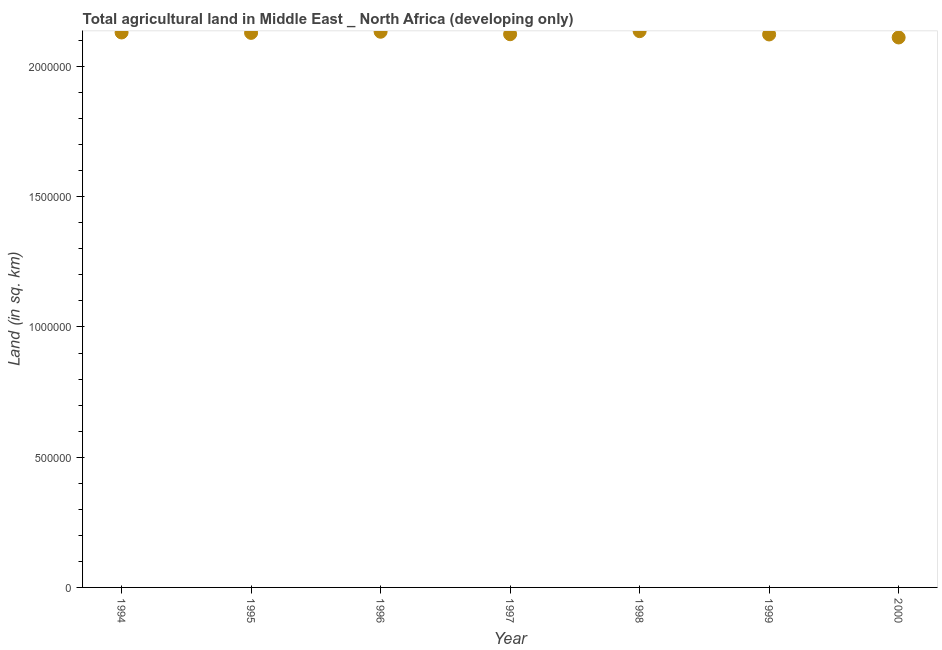What is the agricultural land in 1997?
Provide a short and direct response. 2.12e+06. Across all years, what is the maximum agricultural land?
Your answer should be very brief. 2.14e+06. Across all years, what is the minimum agricultural land?
Make the answer very short. 2.11e+06. In which year was the agricultural land minimum?
Offer a terse response. 2000. What is the sum of the agricultural land?
Provide a succinct answer. 1.49e+07. What is the difference between the agricultural land in 1996 and 1997?
Ensure brevity in your answer.  9495.4. What is the average agricultural land per year?
Ensure brevity in your answer.  2.13e+06. What is the median agricultural land?
Your answer should be very brief. 2.13e+06. In how many years, is the agricultural land greater than 700000 sq. km?
Provide a short and direct response. 7. What is the ratio of the agricultural land in 1998 to that in 2000?
Your answer should be very brief. 1.01. What is the difference between the highest and the second highest agricultural land?
Offer a terse response. 2321.6. What is the difference between the highest and the lowest agricultural land?
Your answer should be compact. 2.43e+04. In how many years, is the agricultural land greater than the average agricultural land taken over all years?
Your answer should be very brief. 4. How many dotlines are there?
Keep it short and to the point. 1. What is the difference between two consecutive major ticks on the Y-axis?
Ensure brevity in your answer.  5.00e+05. Are the values on the major ticks of Y-axis written in scientific E-notation?
Offer a very short reply. No. Does the graph contain any zero values?
Give a very brief answer. No. What is the title of the graph?
Provide a short and direct response. Total agricultural land in Middle East _ North Africa (developing only). What is the label or title of the Y-axis?
Provide a succinct answer. Land (in sq. km). What is the Land (in sq. km) in 1994?
Provide a succinct answer. 2.13e+06. What is the Land (in sq. km) in 1995?
Offer a very short reply. 2.13e+06. What is the Land (in sq. km) in 1996?
Provide a succinct answer. 2.13e+06. What is the Land (in sq. km) in 1997?
Keep it short and to the point. 2.12e+06. What is the Land (in sq. km) in 1998?
Provide a short and direct response. 2.14e+06. What is the Land (in sq. km) in 1999?
Make the answer very short. 2.12e+06. What is the Land (in sq. km) in 2000?
Your response must be concise. 2.11e+06. What is the difference between the Land (in sq. km) in 1994 and 1995?
Give a very brief answer. 1540. What is the difference between the Land (in sq. km) in 1994 and 1996?
Offer a terse response. -2814.6. What is the difference between the Land (in sq. km) in 1994 and 1997?
Your answer should be compact. 6680.8. What is the difference between the Land (in sq. km) in 1994 and 1998?
Provide a succinct answer. -5136.2. What is the difference between the Land (in sq. km) in 1994 and 1999?
Keep it short and to the point. 7615. What is the difference between the Land (in sq. km) in 1994 and 2000?
Offer a terse response. 1.92e+04. What is the difference between the Land (in sq. km) in 1995 and 1996?
Make the answer very short. -4354.6. What is the difference between the Land (in sq. km) in 1995 and 1997?
Keep it short and to the point. 5140.8. What is the difference between the Land (in sq. km) in 1995 and 1998?
Your answer should be compact. -6676.2. What is the difference between the Land (in sq. km) in 1995 and 1999?
Your answer should be compact. 6075. What is the difference between the Land (in sq. km) in 1995 and 2000?
Your answer should be very brief. 1.76e+04. What is the difference between the Land (in sq. km) in 1996 and 1997?
Your answer should be compact. 9495.4. What is the difference between the Land (in sq. km) in 1996 and 1998?
Your answer should be very brief. -2321.6. What is the difference between the Land (in sq. km) in 1996 and 1999?
Offer a terse response. 1.04e+04. What is the difference between the Land (in sq. km) in 1996 and 2000?
Provide a short and direct response. 2.20e+04. What is the difference between the Land (in sq. km) in 1997 and 1998?
Keep it short and to the point. -1.18e+04. What is the difference between the Land (in sq. km) in 1997 and 1999?
Offer a very short reply. 934.2. What is the difference between the Land (in sq. km) in 1997 and 2000?
Make the answer very short. 1.25e+04. What is the difference between the Land (in sq. km) in 1998 and 1999?
Your answer should be compact. 1.28e+04. What is the difference between the Land (in sq. km) in 1998 and 2000?
Offer a very short reply. 2.43e+04. What is the difference between the Land (in sq. km) in 1999 and 2000?
Your response must be concise. 1.15e+04. What is the ratio of the Land (in sq. km) in 1994 to that in 1995?
Offer a very short reply. 1. What is the ratio of the Land (in sq. km) in 1994 to that in 1996?
Give a very brief answer. 1. What is the ratio of the Land (in sq. km) in 1994 to that in 1998?
Provide a succinct answer. 1. What is the ratio of the Land (in sq. km) in 1994 to that in 1999?
Your response must be concise. 1. What is the ratio of the Land (in sq. km) in 1995 to that in 1996?
Your answer should be compact. 1. What is the ratio of the Land (in sq. km) in 1995 to that in 1998?
Your response must be concise. 1. What is the ratio of the Land (in sq. km) in 1995 to that in 1999?
Ensure brevity in your answer.  1. What is the ratio of the Land (in sq. km) in 1996 to that in 1997?
Offer a terse response. 1. What is the ratio of the Land (in sq. km) in 1996 to that in 1998?
Make the answer very short. 1. What is the ratio of the Land (in sq. km) in 1997 to that in 1998?
Keep it short and to the point. 0.99. What is the ratio of the Land (in sq. km) in 1997 to that in 1999?
Make the answer very short. 1. 